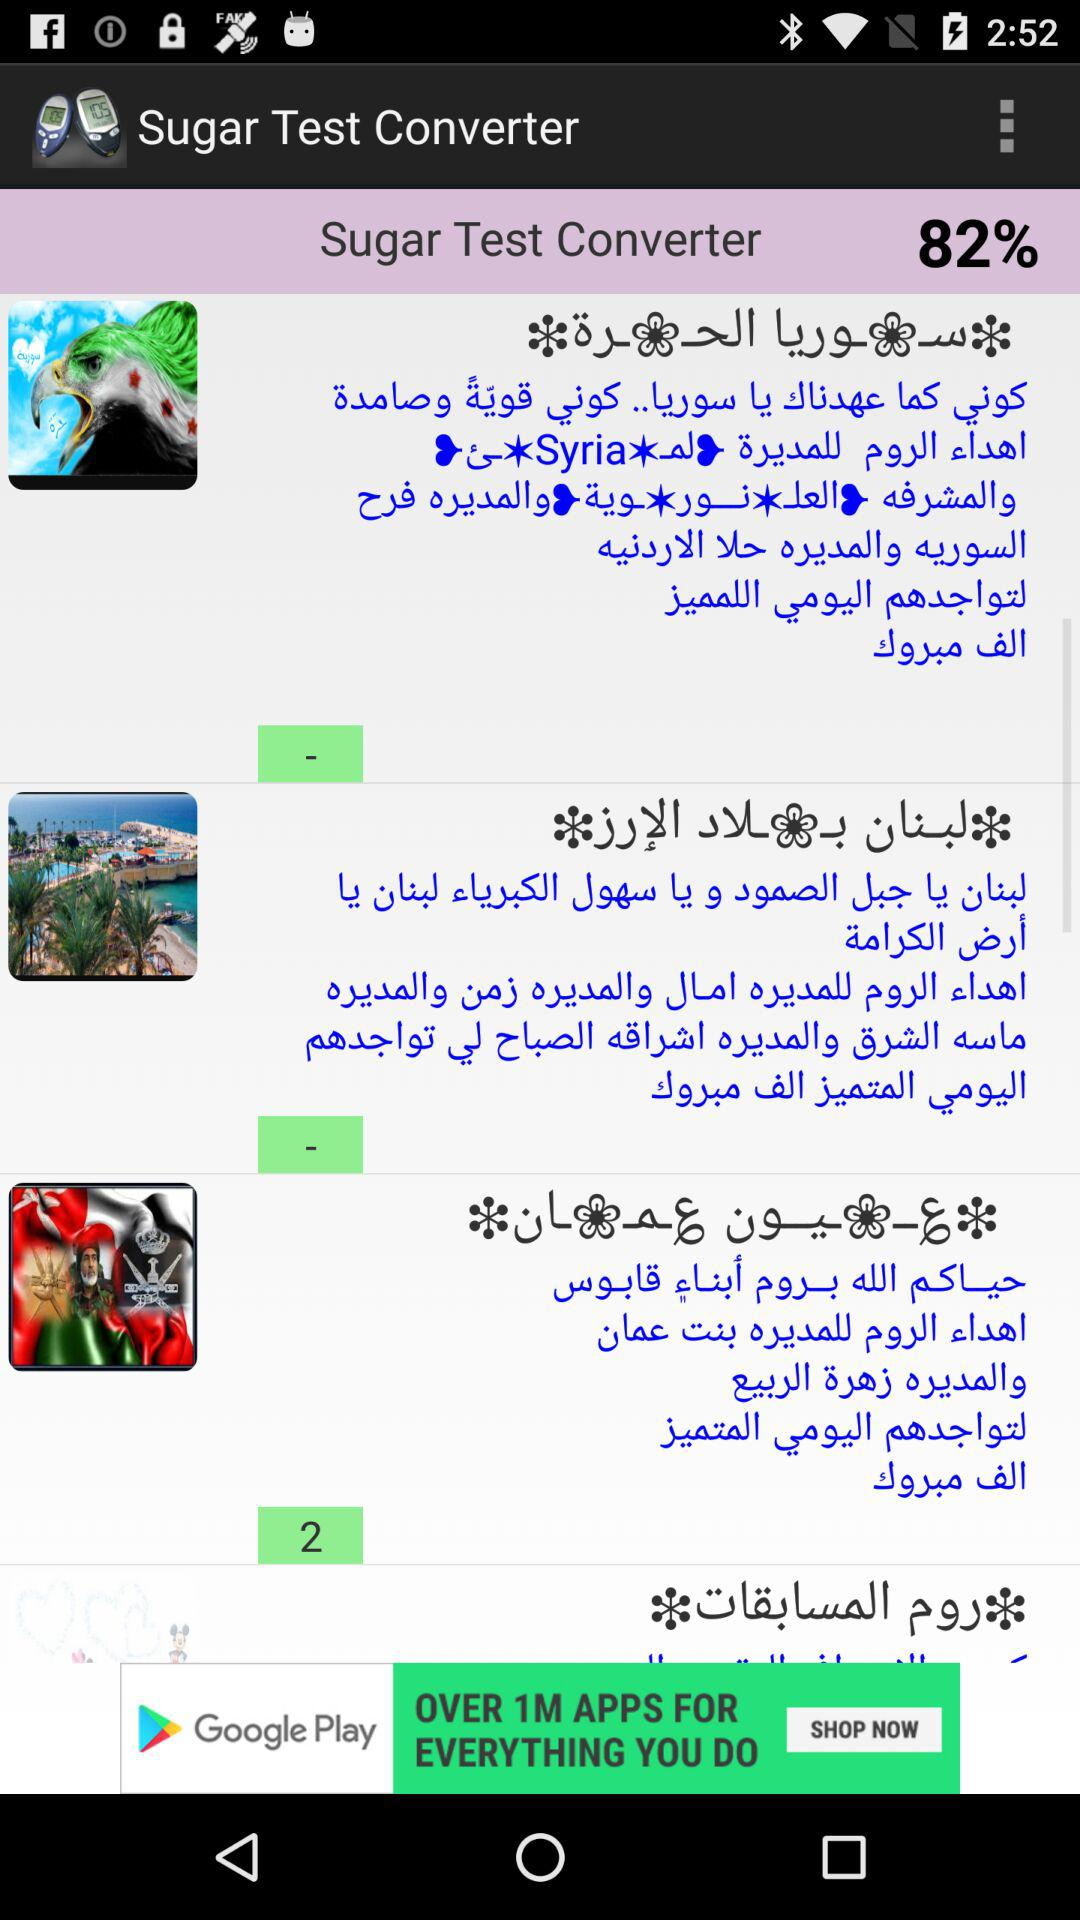What is the "Sugar Test Converter" percentage? The "Sugar Test Converter" percentage is 82. 